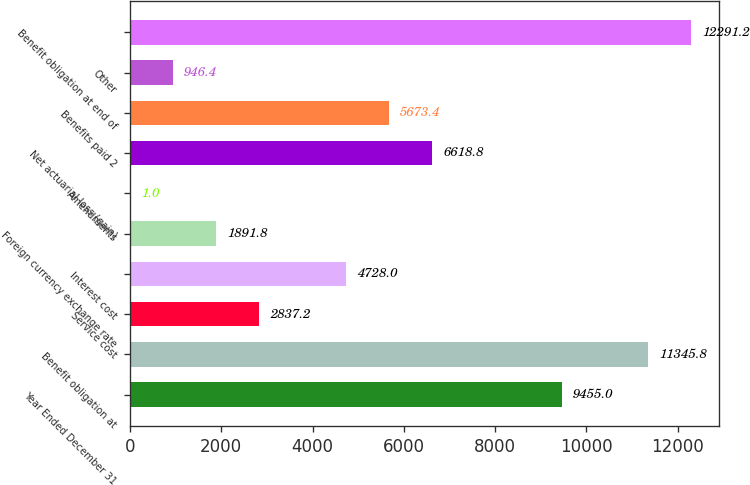Convert chart. <chart><loc_0><loc_0><loc_500><loc_500><bar_chart><fcel>Year Ended December 31<fcel>Benefit obligation at<fcel>Service cost<fcel>Interest cost<fcel>Foreign currency exchange rate<fcel>Amendments<fcel>Net actuarial loss (gain)<fcel>Benefits paid 2<fcel>Other<fcel>Benefit obligation at end of<nl><fcel>9455<fcel>11345.8<fcel>2837.2<fcel>4728<fcel>1891.8<fcel>1<fcel>6618.8<fcel>5673.4<fcel>946.4<fcel>12291.2<nl></chart> 